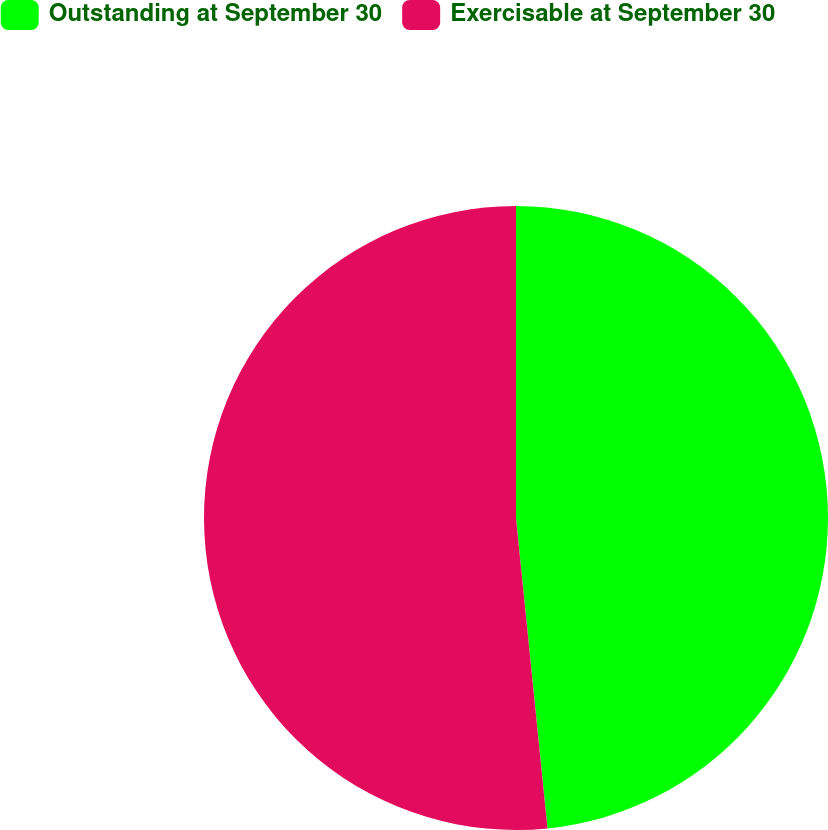Convert chart. <chart><loc_0><loc_0><loc_500><loc_500><pie_chart><fcel>Outstanding at September 30<fcel>Exercisable at September 30<nl><fcel>48.39%<fcel>51.61%<nl></chart> 